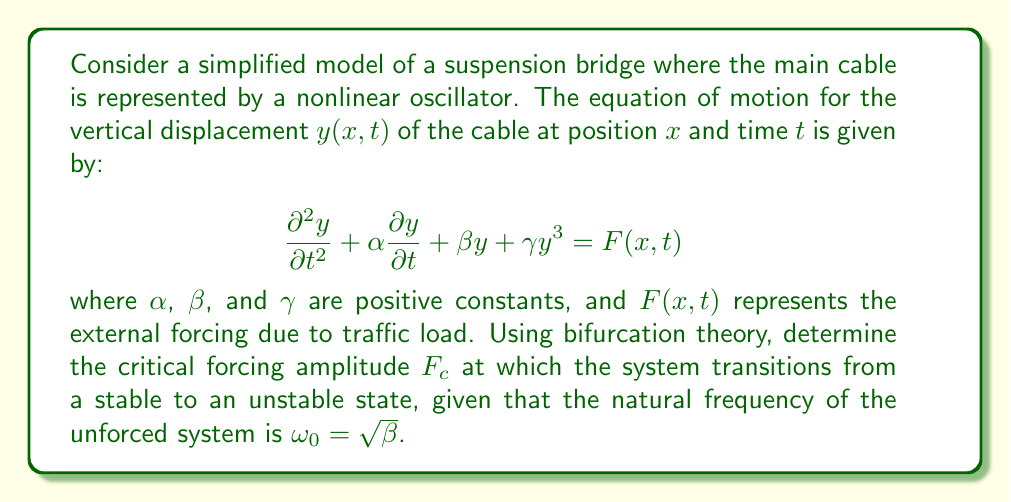Help me with this question. To solve this problem, we'll follow these steps:

1) First, we recognize that this equation represents a forced Duffing oscillator, which is known to exhibit bifurcations.

2) In the absence of forcing $(F(x,t) = 0)$, the system has a stable equilibrium at $y = 0$ when $\beta > 0$.

3) To analyze the stability under forcing, we consider a harmonic forcing function:

   $$F(x,t) = F_0 \cos(\omega t)$$

   where $F_0$ is the forcing amplitude and $\omega$ is the forcing frequency.

4) For simplicity, we'll assume the forcing frequency is close to the natural frequency: $\omega \approx \omega_0 = \sqrt{\beta}$.

5) The method of averaging can be used to analyze this system. The averaged equations in polar coordinates $(r, \theta)$ are:

   $$\frac{dr}{dt} = -\frac{\alpha}{2}r + \frac{F_0}{2\omega_0}\sin\theta$$
   $$\frac{d\theta}{dt} = -\sigma - \frac{3\gamma}{8\omega_0}r^2 + \frac{F_0}{2\omega_0 r}\cos\theta$$

   where $\sigma = \omega - \omega_0$ is the detuning parameter.

6) The bifurcation occurs when the Jacobian of this system has a zero eigenvalue. This happens when:

   $$\frac{F_0^2}{4\omega_0^2} = \frac{\alpha^2}{4} + \sigma^2$$

7) The critical forcing amplitude $F_c$ occurs at the minimum of this curve, which is when $\sigma = 0$ (i.e., when the forcing frequency exactly matches the natural frequency).

8) Therefore, the critical forcing amplitude is:

   $$F_c = \alpha \omega_0 = \alpha \sqrt{\beta}$$

This $F_c$ represents the threshold at which the system transitions from a stable response to an unstable one, potentially leading to large amplitude oscillations or even structural failure.
Answer: $F_c = \alpha \sqrt{\beta}$ 